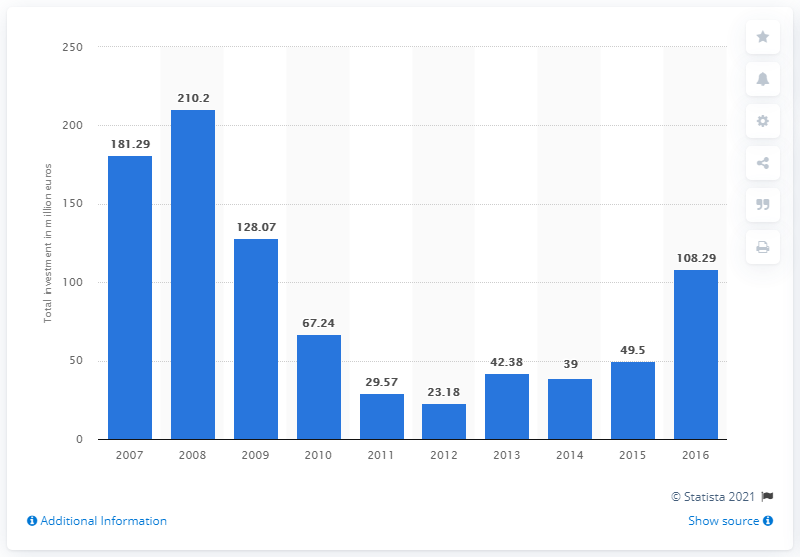Specify some key components in this picture. The largest total value of private equity investments was found in 2008. The average of the highest and lowest bars is 116.69. The year that recorded the highest bar was 2008. According to a report in 2016, private equity investments had a value of 108.29. 